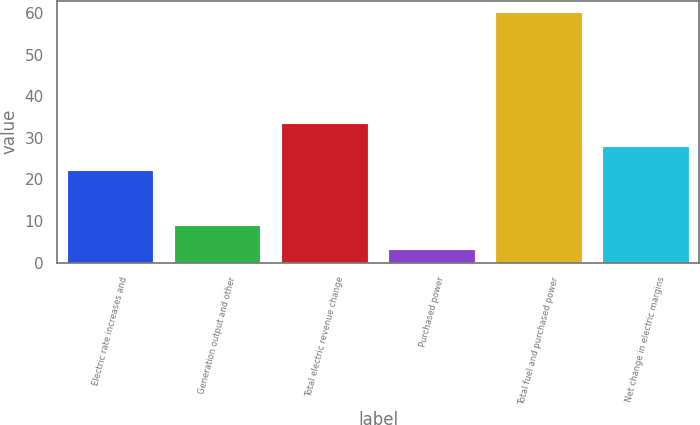<chart> <loc_0><loc_0><loc_500><loc_500><bar_chart><fcel>Electric rate increases and<fcel>Generation output and other<fcel>Total electric revenue change<fcel>Purchased power<fcel>Total fuel and purchased power<fcel>Net change in electric margins<nl><fcel>22<fcel>8.7<fcel>33.4<fcel>3<fcel>60<fcel>27.7<nl></chart> 